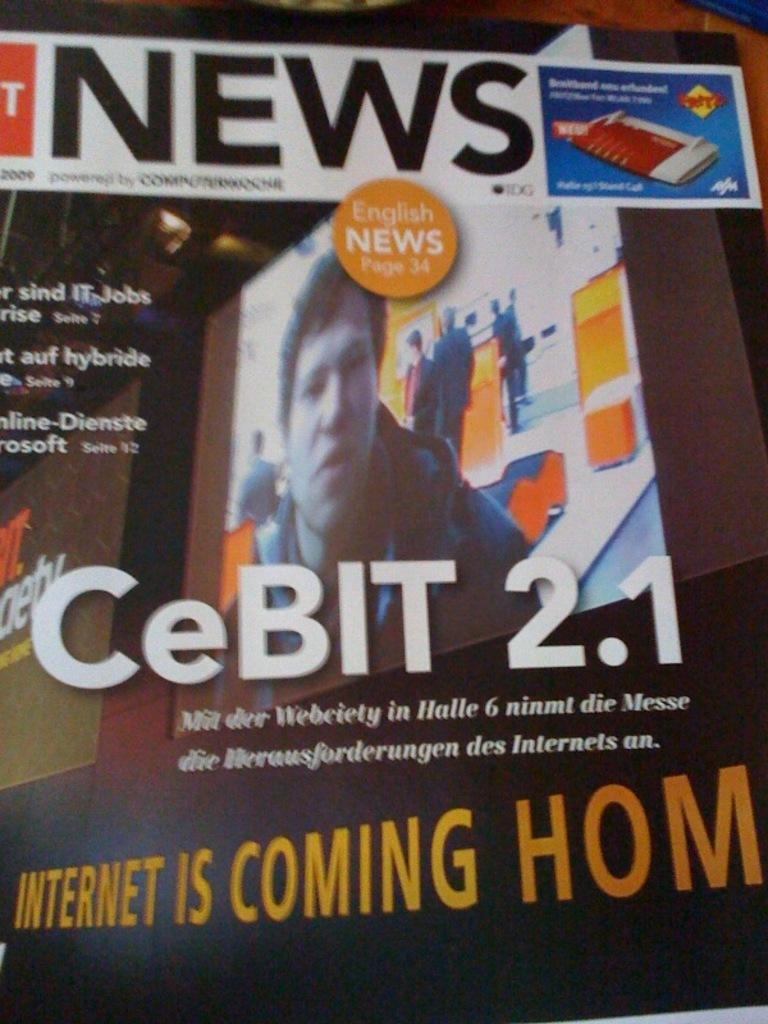<image>
Describe the image concisely. A book about CeBIT 2.1 that says internet is coming home 